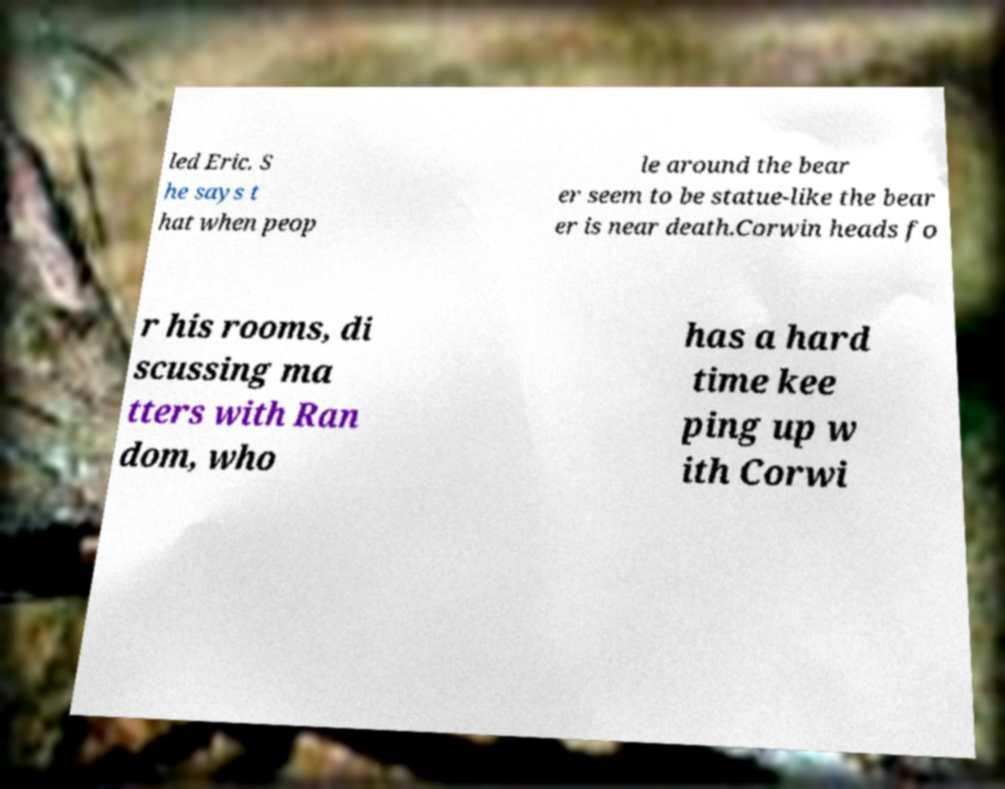Please read and relay the text visible in this image. What does it say? led Eric. S he says t hat when peop le around the bear er seem to be statue-like the bear er is near death.Corwin heads fo r his rooms, di scussing ma tters with Ran dom, who has a hard time kee ping up w ith Corwi 